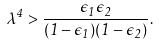<formula> <loc_0><loc_0><loc_500><loc_500>\lambda ^ { 4 } > \frac { \epsilon _ { 1 } \epsilon _ { 2 } } { ( 1 - \epsilon _ { 1 } ) ( 1 - \epsilon _ { 2 } ) } .</formula> 